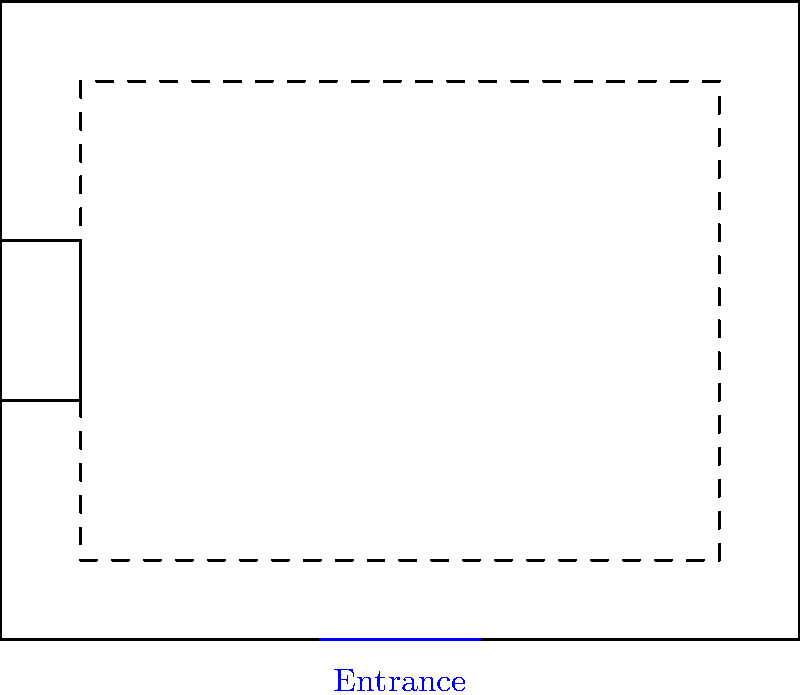Given the floor plan of the mosque for a community event, what is the maximum number of additional people that can be accommodated if the seating capacity of each area is increased by 25% while maintaining safe distancing and proper circulation? To solve this problem, we need to follow these steps:

1. Identify the current seating capacity:
   - There are 9 seating areas, each with a capacity of 20 people.
   - Total current capacity = $9 \times 20 = 180$ people

2. Calculate the increased capacity for each seating area:
   - 25% increase means multiplying the current capacity by 1.25
   - New capacity per area = $20 \times 1.25 = 25$ people

3. Calculate the new total capacity:
   - New total capacity = $9 \times 25 = 225$ people

4. Determine the additional people that can be accommodated:
   - Additional people = New total capacity - Current capacity
   - Additional people = $225 - 180 = 45$ people

Therefore, by increasing the seating capacity of each area by 25%, an additional 45 people can be accommodated while maintaining safe distancing and proper circulation.
Answer: 45 people 